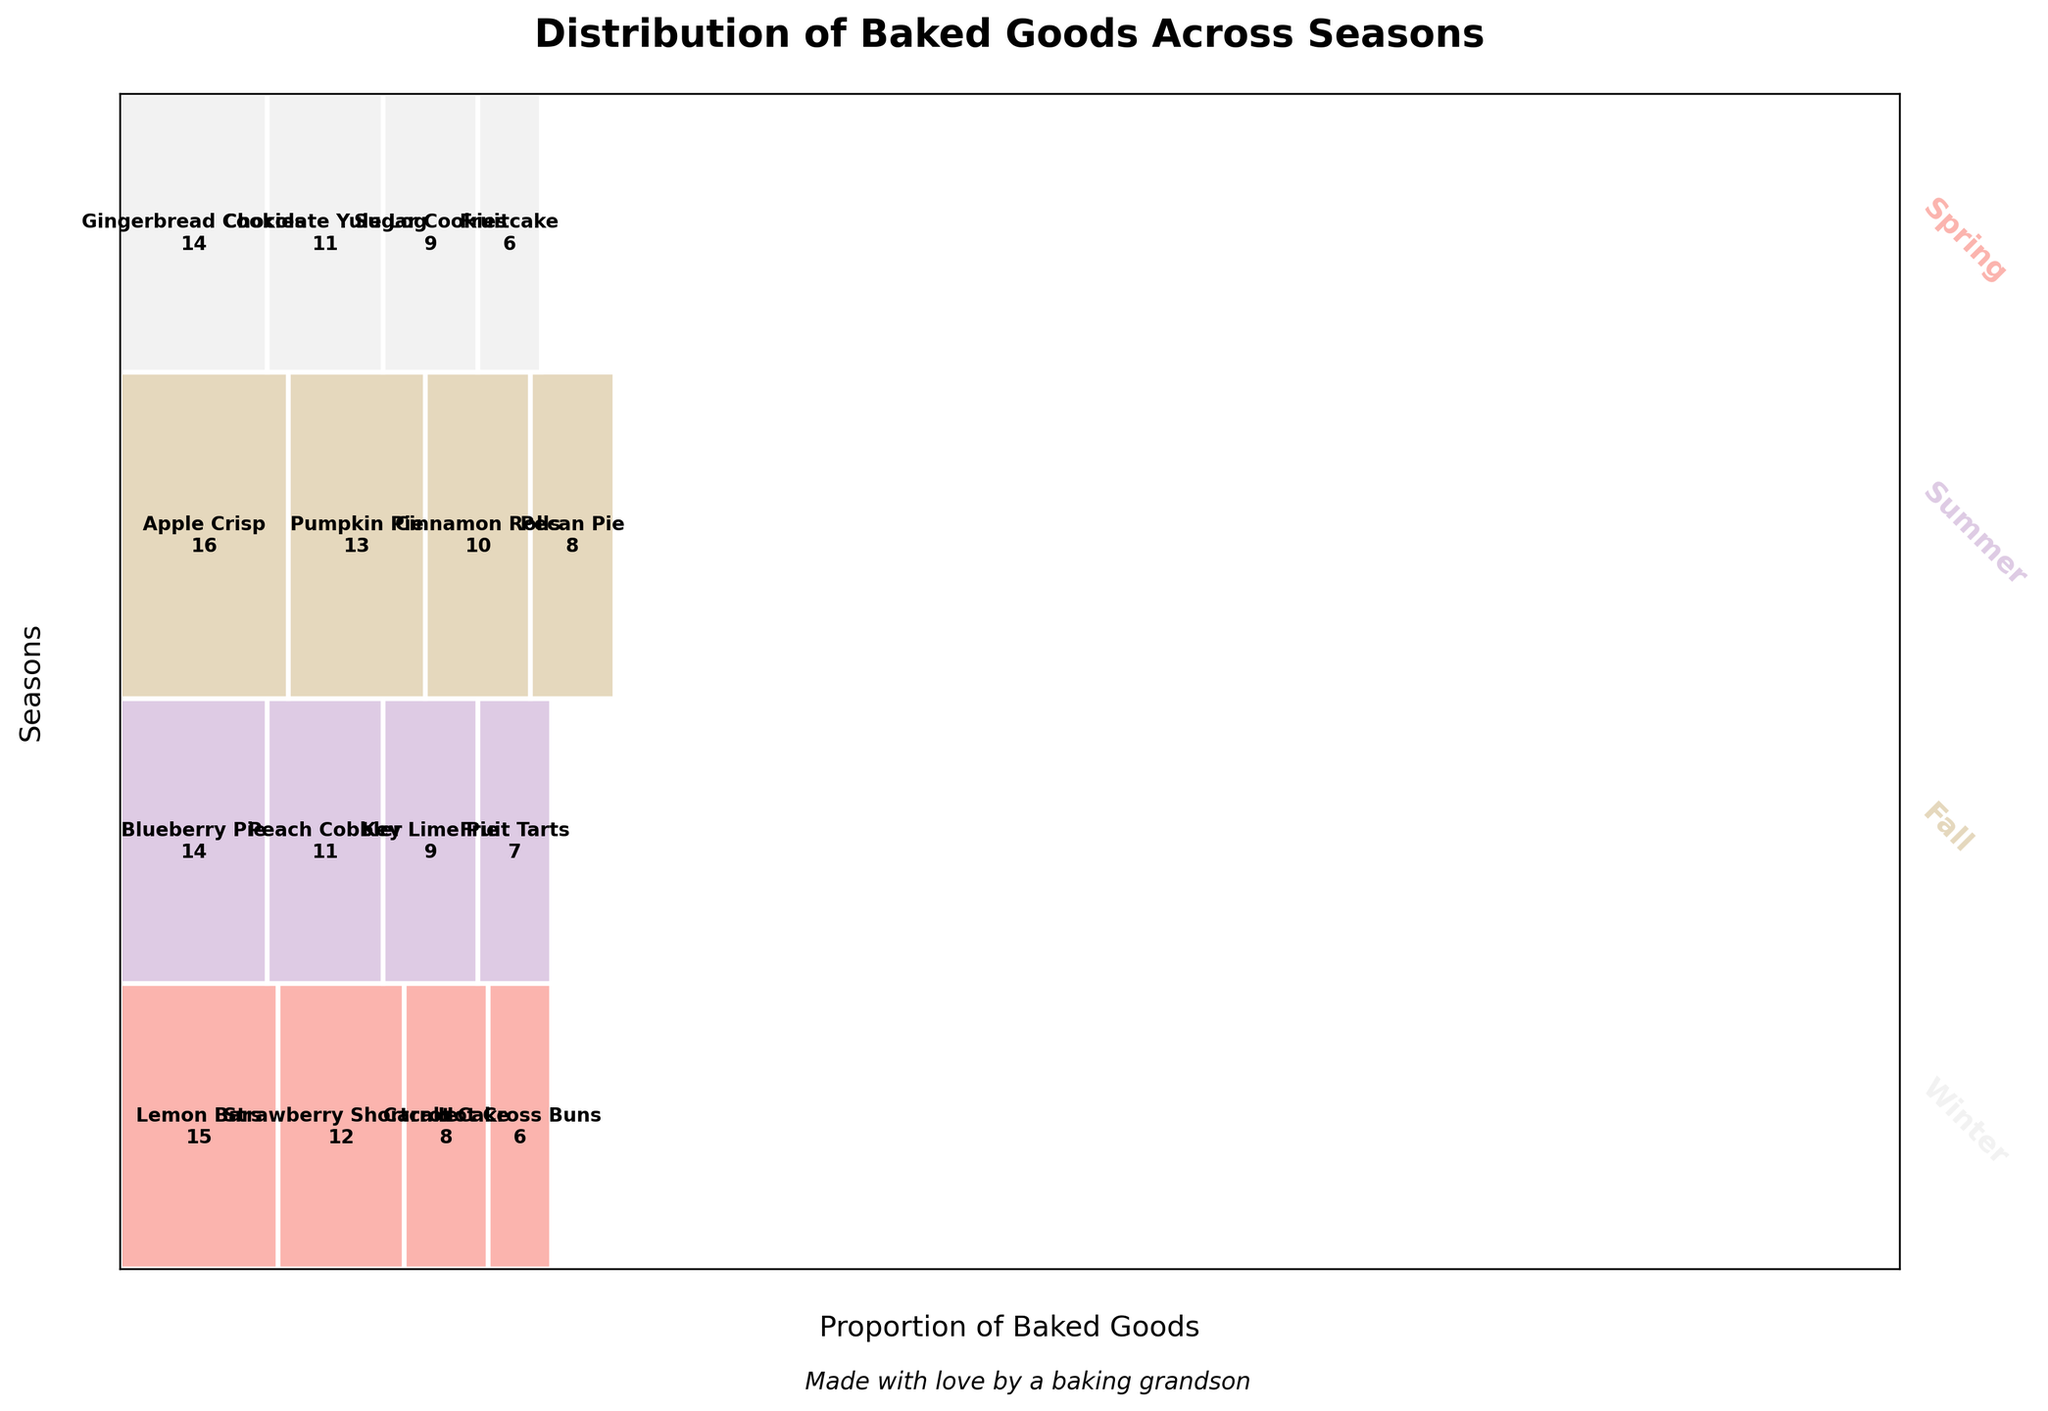What is the title of the plot? The title of the plot is usually displayed at the top. According to the provided information, it is "Distribution of Baked Goods Across Seasons".
Answer: Distribution of Baked Goods Across Seasons Which season appears to have the highest total frequency of baked goods? Each season's total frequency can be determined by the height each season occupies on the y-axis in the plot. Fall covers the largest vertical space, indicating it has the highest total frequency.
Answer: Fall What baked good has the highest frequency in the Summer? In the Summer section, the largest rectangle represents the baked good with the highest frequency. The largest rectangle in Summer is Blueberry Pie with 14.
Answer: Blueberry Pie Which baked good is the most common across all seasons? The width of each rectangle on the x-axis represents the total frequency of each baked good across all seasons. From the plot, Apple Crisp has the widest rectangle.
Answer: Apple Crisp How does the frequency of Pumpkin Pie in Fall compare to Lemon Bars in Spring? Pumpkin Pie in Fall has a frequency of 13 and Lemon Bars in Spring have a higher frequency of 15.
Answer: Lemon Bars have more than Pumpkin Pie How many different baked goods are shared in Winter? The number of different baked goods is indicated by the number of distinct rectangles in the Winter section of the plot. There are four rectangles in Winter: Gingerbread Cookies, Chocolate Yule Log, Sugar Cookies, and Fruitcake.
Answer: 4 Is the frequency of Strawberry Shortcake in Spring greater than the frequency of Fruitcake in Winter? In the Spring section, Strawberry Shortcake has a frequency of 12. In Winter, Fruitcake has a frequency of 6. 12 is greater than 6.
Answer: Yes Which season has the lowest proportion of baked goods shared? The proportion of baked goods shared in each season is represented by the height of the segment that season occupies. Winter has the shortest height segment, indicating it shares the lowest proportion of baked goods.
Answer: Winter 